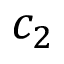Convert formula to latex. <formula><loc_0><loc_0><loc_500><loc_500>c _ { 2 }</formula> 